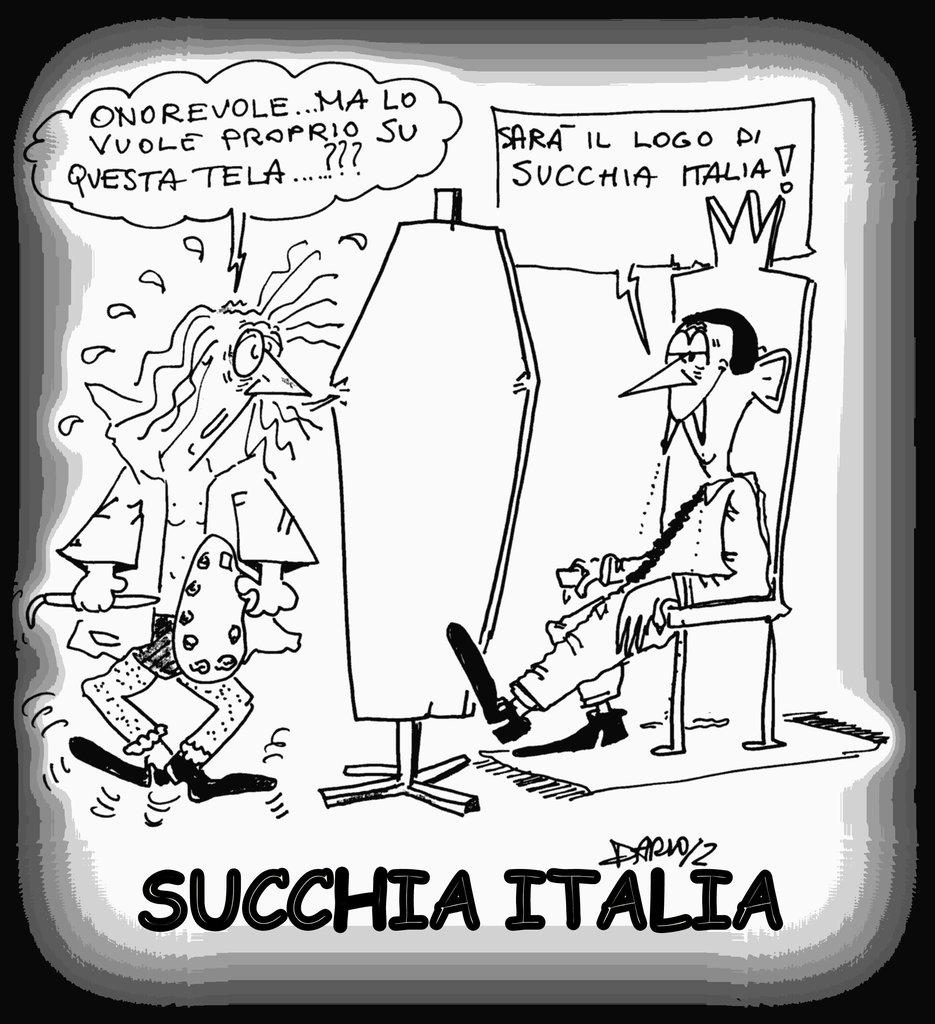What type of visual is the image? The image is a poster. What is the man in the poster doing? The man is sitting on a chair in the poster. What else can be seen in the poster besides the man? There is some text present in the poster. How many sticks are being used by the man in the poster? There are no sticks visible in the poster; the man is sitting on a chair. What type of letters can be seen on the tray in the poster? There is no tray present in the poster, so it is not possible to determine what type of letters might be on it. 